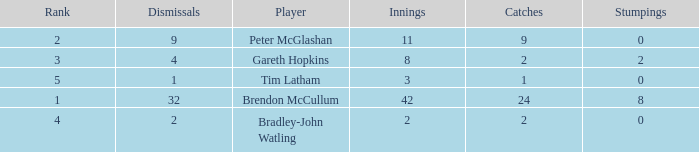How many innings had a total of 2 catches and 0 stumpings? 1.0. 